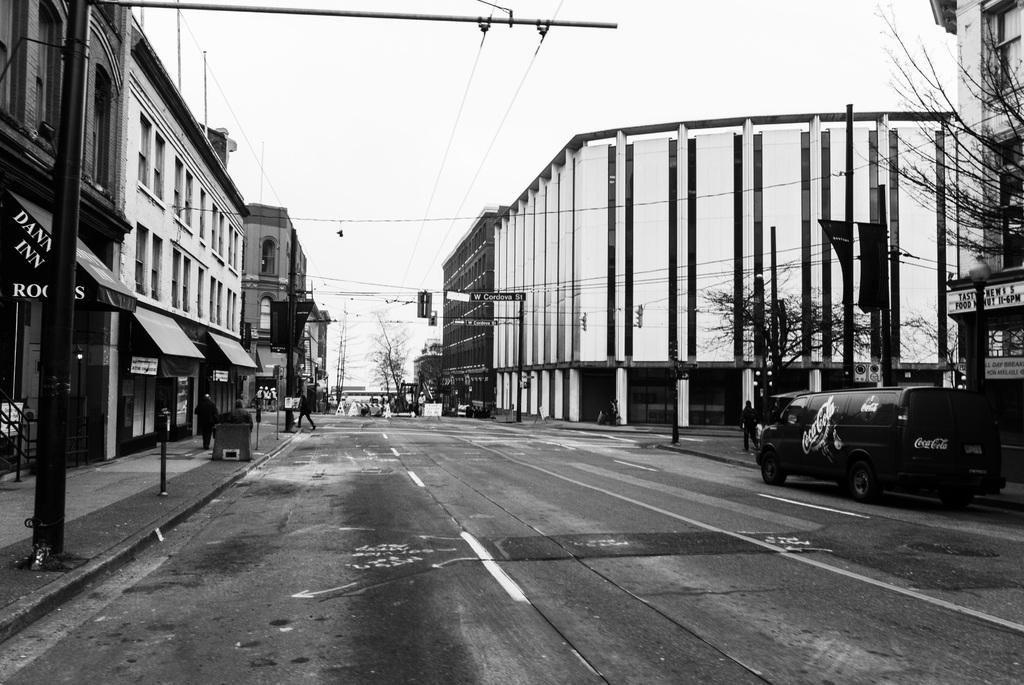What is the color scheme of the image? The image is black and white. What type of structures can be seen in the image? There are buildings in the image. What other objects are present in the image? There are poles, trees, people, a vehicle, sky, boards, and other objects in the image. What is written on the boards? Something is written on the boards, but we cannot determine the specific message from the image. Can you describe the objects in the image? There are various objects in the image, but we cannot identify them specifically based on the provided facts. Where is the stove located in the image? There is no stove present in the image. Can you describe the bat flying in the sky in the image? There is no bat present in the image. What type of drug is being sold on the boards in the image? There is no drug present in the image, and nothing suggests that the boards are related to drug sales. 